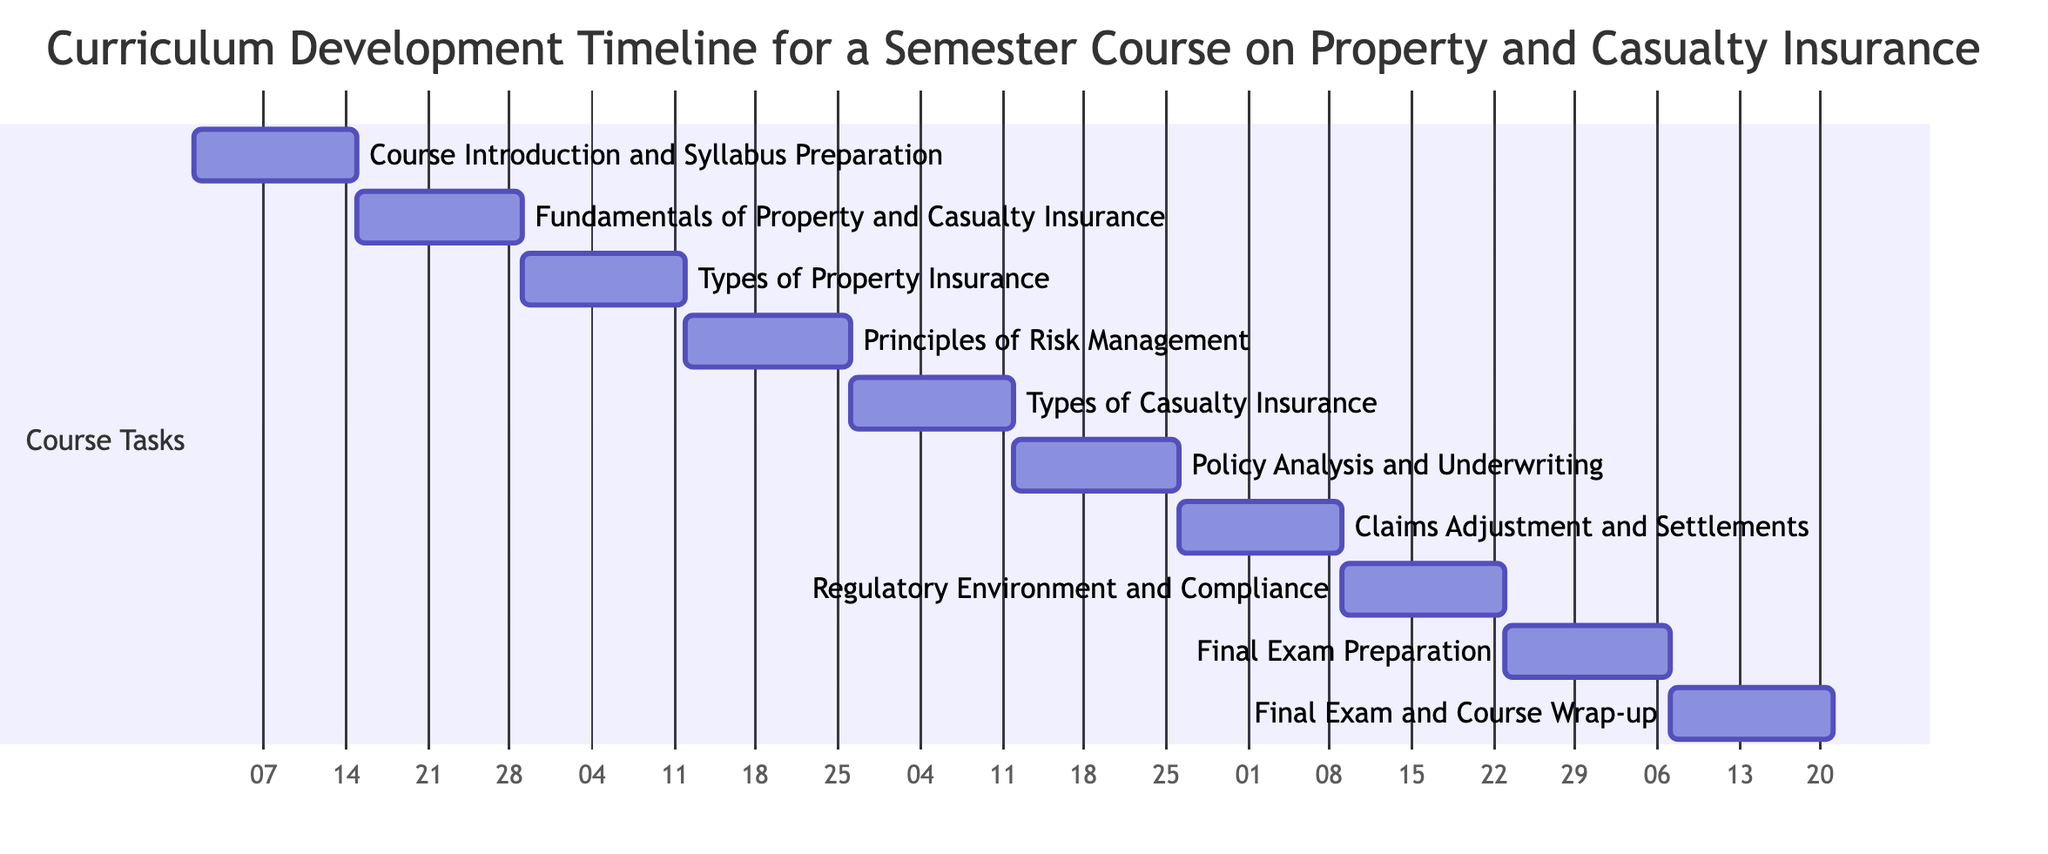What is the duration of the course introduction task? The task "Course Introduction and Syllabus Preparation" is scheduled for week 1 to week 2, which spans 2 weeks in total.
Answer: 2 weeks Which task follows "Claims Adjustment and Settlements"? Looking at the Gantt chart, "Regulatory Environment and Compliance" is scheduled directly after "Claims Adjustment and Settlements," making it the next task in sequence.
Answer: Regulatory Environment and Compliance How many tasks are there in the curriculum? By counting each task listed in the Gantt chart, we find there are a total of 10 tasks outlined in the curriculum timeline.
Answer: 10 tasks What is the starting week for the "Final Exam and Course Wrap-up"? Referring to the diagram, the task "Final Exam and Course Wrap-up" begins in week 19, which is its assigned starting week.
Answer: Week 19 How many weeks are allocated for "Principles of Risk Management"? The Gantt chart indicates that "Principles of Risk Management" runs from week 7 to week 8, thereby covering a span of 2 weeks.
Answer: 2 weeks Which task has the longest gap before its start after "Types of Casualty Insurance"? The task "Policy Analysis and Underwriting" follows immediately after "Types of Casualty Insurance" without any gap, which means it does not have a long gap. In fact, there are no long gaps between these consecutive tasks.
Answer: No long gap What is the end week for the course? The last task, "Final Exam and Course Wrap-up," is scheduled to end in week 20, marking the conclusion of the curriculum.
Answer: Week 20 Which task begins after the "Fundamentals of Property and Casualty Insurance"? According to the Gantt chart, "Types of Property Insurance" immediately follows "Fundamentals of Property and Casualty Insurance," starting in week 5.
Answer: Types of Property Insurance What is the total time span of the entire curriculum from start to end? The first task starts in week 1 and the last task ends in week 20, which gives us a total span of 20 weeks for the complete curriculum.
Answer: 20 weeks 